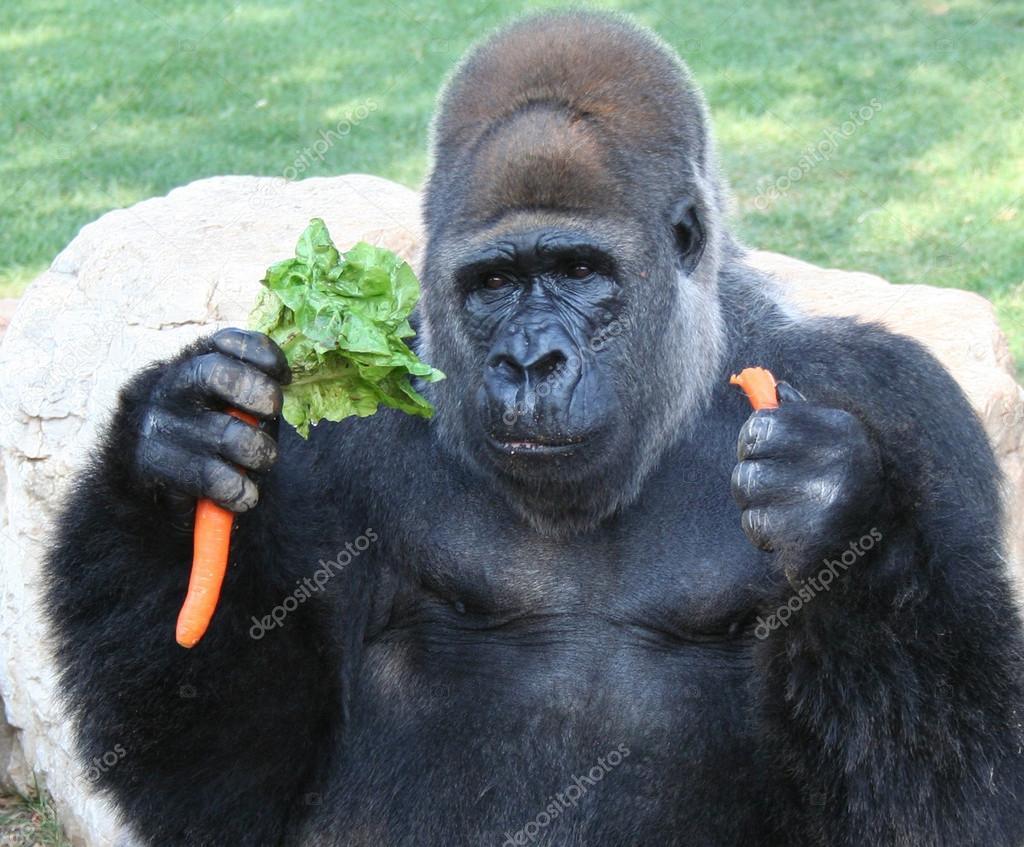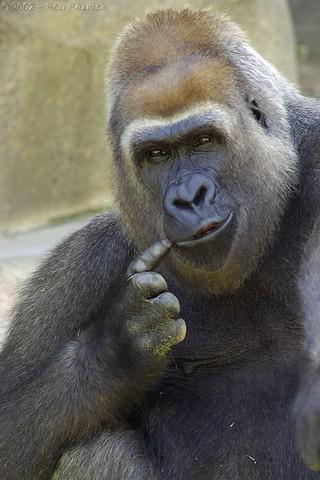The first image is the image on the left, the second image is the image on the right. Assess this claim about the two images: "The animal in the image on the left is holding food.". Correct or not? Answer yes or no. Yes. 